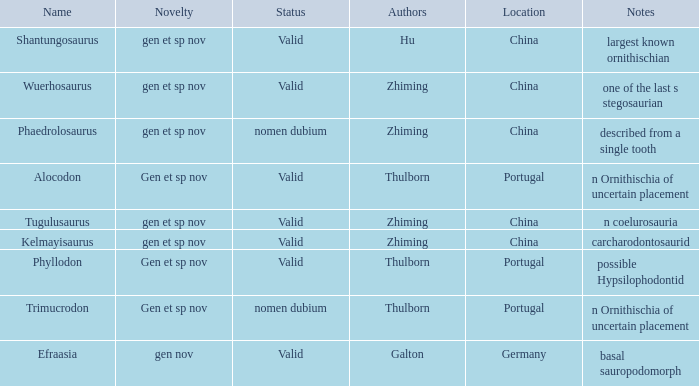What is the Novelty of the dinosaur that was named by the Author, Zhiming, and whose Notes are, "carcharodontosaurid"? Gen et sp nov. 